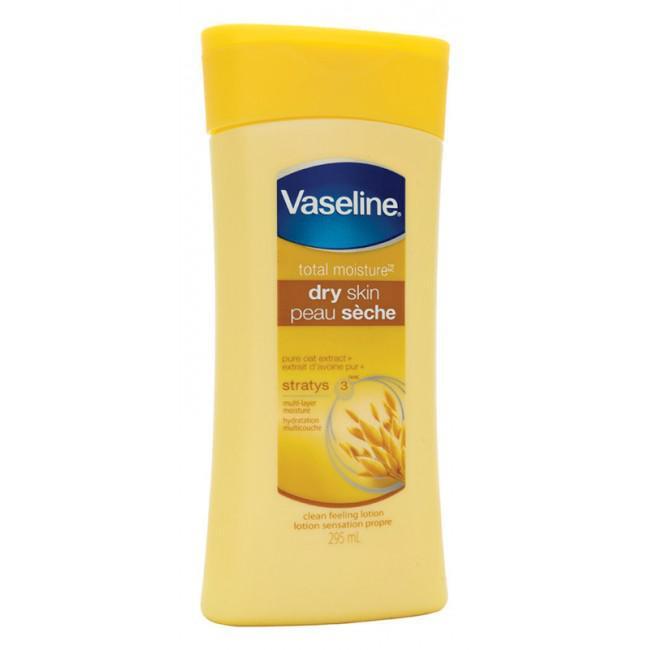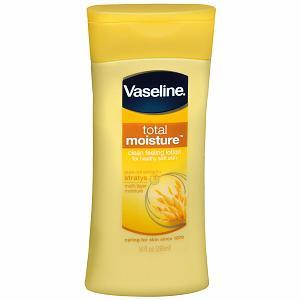The first image is the image on the left, the second image is the image on the right. Examine the images to the left and right. Is the description "There are two yellow bottles of lotion" accurate? Answer yes or no. Yes. 